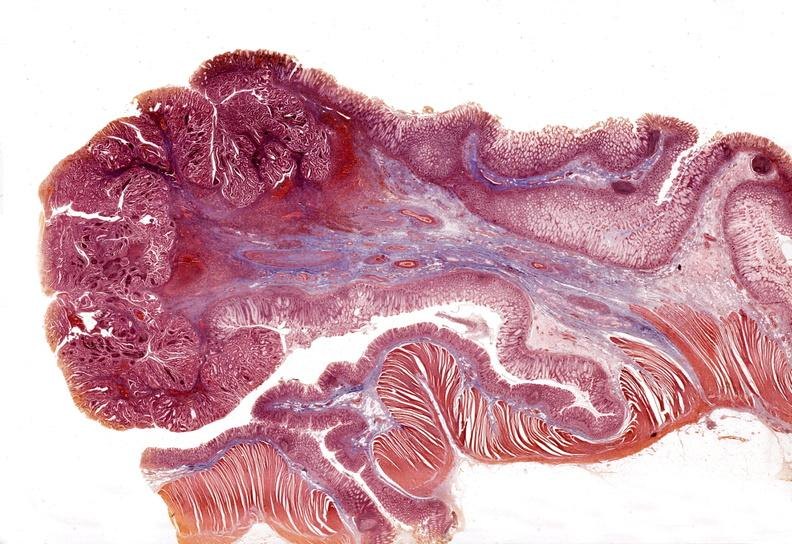where is this from?
Answer the question using a single word or phrase. Gastrointestinal system 